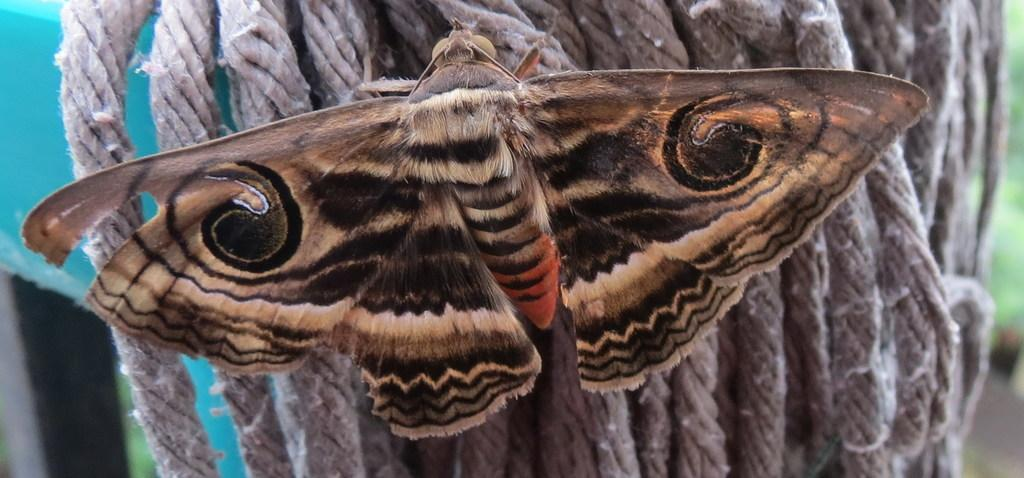What is the main subject of the image? The main subject of the image is a fly. Where is the fly located in the image? The fly is on a rope in the image. How many hens are present in the image? There are no hens present in the image; it only features a fly on a rope. What type of death can be seen in the image? There is no death depicted in the image; it only features a fly on a rope. 